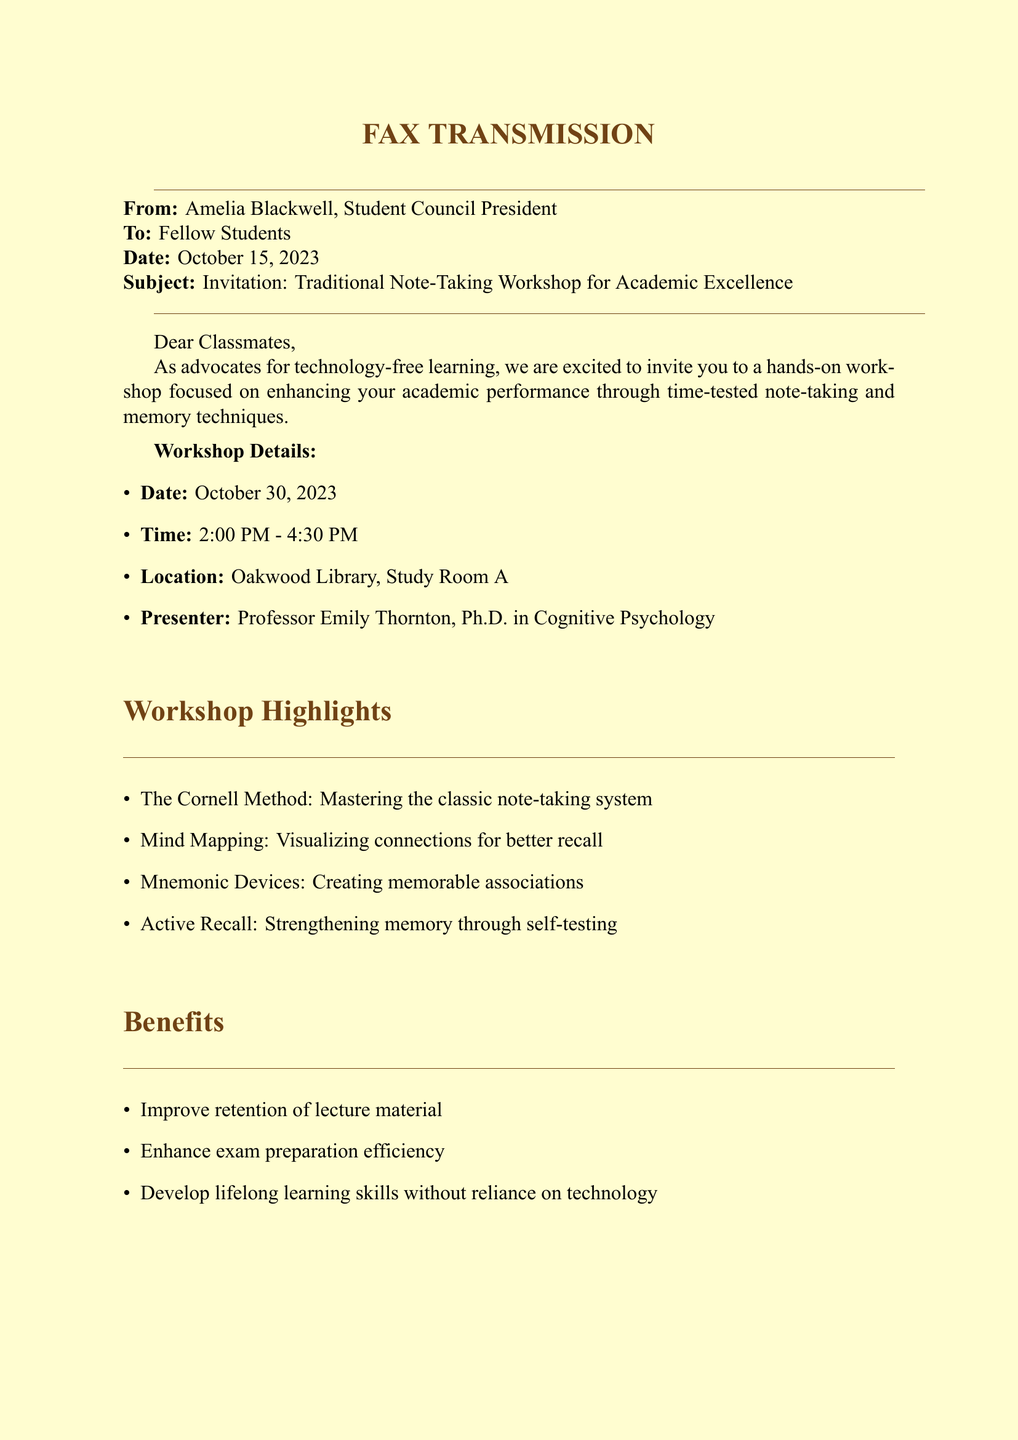What is the date of the workshop? The date of the workshop is explicitly stated in the document as October 30, 2023.
Answer: October 30, 2023 Who is the presenter of the workshop? The document provides the name and title of the presenter, which is Professor Emily Thornton, Ph.D. in Cognitive Psychology.
Answer: Professor Emily Thornton, Ph.D What time does the workshop start? The starting time is clearly indicated in the document as 2:00 PM.
Answer: 2:00 PM What is the location of the workshop? The specific location for the workshop is mentioned in the document as Oakwood Library, Study Room A.
Answer: Oakwood Library, Study Room A What is one of the highlights of the workshop? The document lists several highlights, one of which is The Cornell Method.
Answer: The Cornell Method How can students RSVP for the workshop? The method of RSVP is described in the document, which states to sign up on the bulletin board outside the Student Council office.
Answer: Bulletin board outside the Student Council office What are the benefits of attending the workshop? The document lists several benefits, one of which is to improve retention of lecture material.
Answer: Improve retention of lecture material What is the purpose of the workshop? The document states its purpose is to enhance academic performance through traditional note-taking and memory techniques.
Answer: Enhance academic performance What type of document is this? The document is identified as a fax transmission, as mentioned at the top.
Answer: Fax transmission 